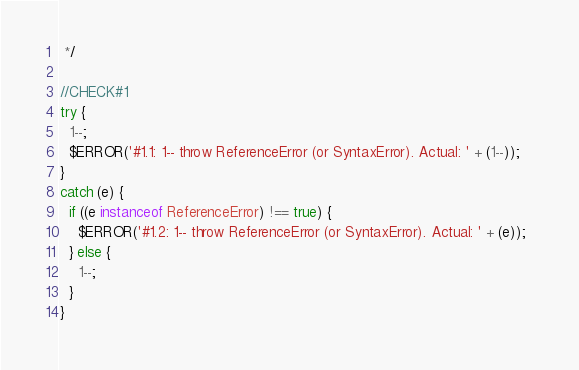Convert code to text. <code><loc_0><loc_0><loc_500><loc_500><_JavaScript_> */

//CHECK#1
try {
  1--;
  $ERROR('#1.1: 1-- throw ReferenceError (or SyntaxError). Actual: ' + (1--));  
}
catch (e) {
  if ((e instanceof ReferenceError) !== true) {
    $ERROR('#1.2: 1-- throw ReferenceError (or SyntaxError). Actual: ' + (e));  
  } else {
    1--;
  }
}

</code> 